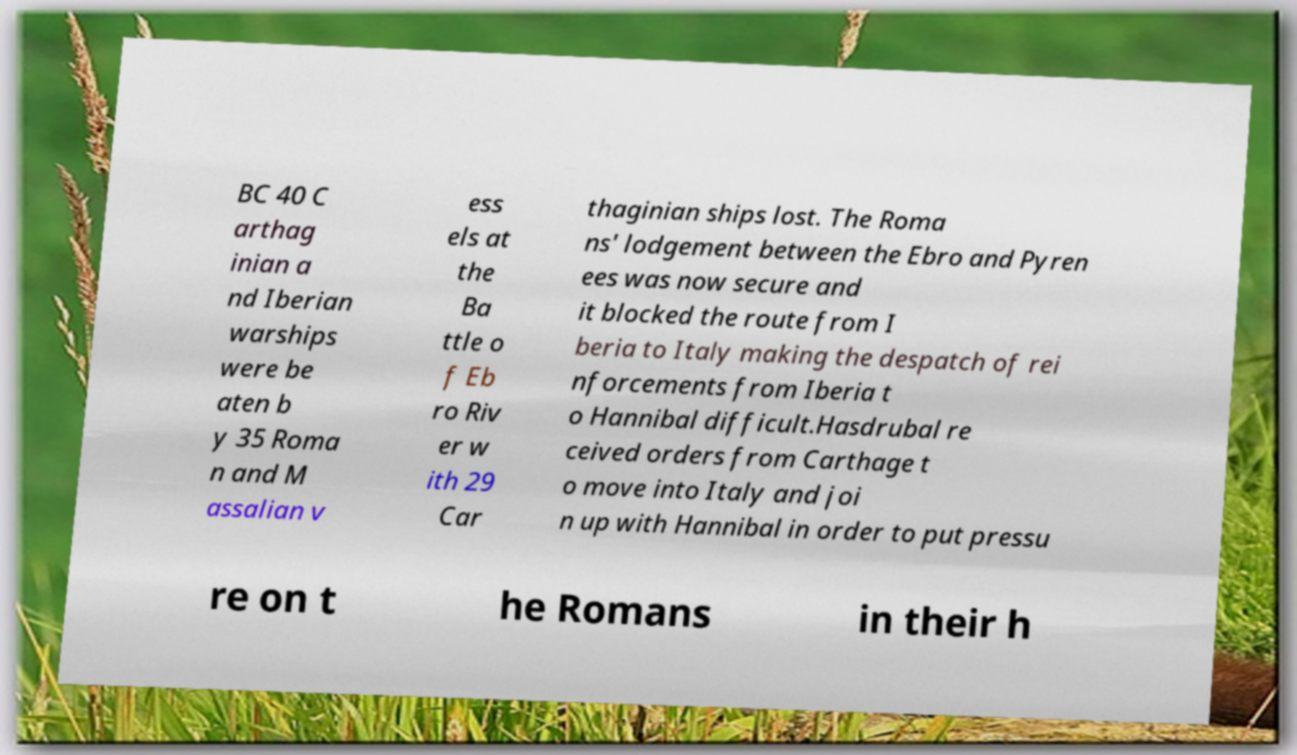Can you read and provide the text displayed in the image?This photo seems to have some interesting text. Can you extract and type it out for me? BC 40 C arthag inian a nd Iberian warships were be aten b y 35 Roma n and M assalian v ess els at the Ba ttle o f Eb ro Riv er w ith 29 Car thaginian ships lost. The Roma ns' lodgement between the Ebro and Pyren ees was now secure and it blocked the route from I beria to Italy making the despatch of rei nforcements from Iberia t o Hannibal difficult.Hasdrubal re ceived orders from Carthage t o move into Italy and joi n up with Hannibal in order to put pressu re on t he Romans in their h 